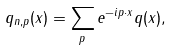<formula> <loc_0><loc_0><loc_500><loc_500>q _ { n , p } ( x ) = \sum _ { p } e ^ { - i p \cdot x } q ( x ) ,</formula> 